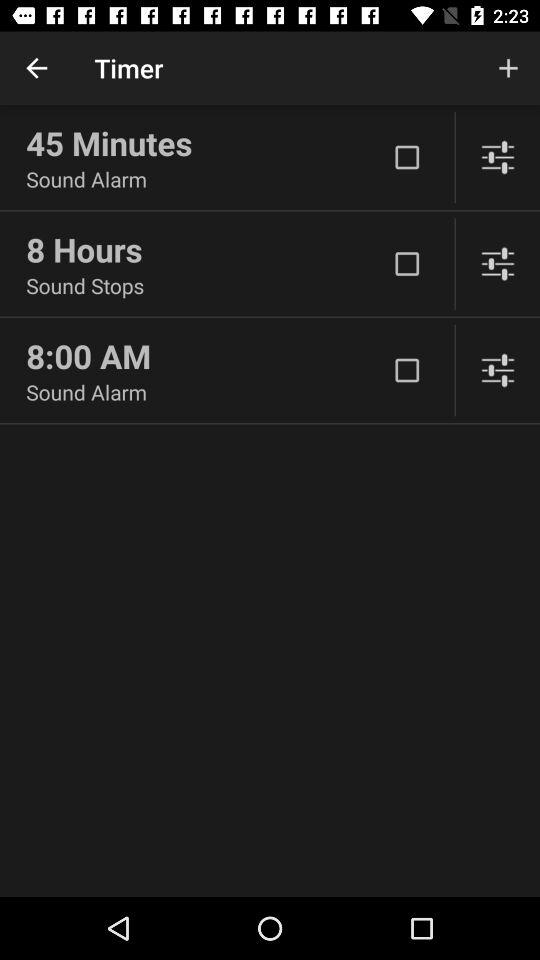Which item has the longest text?
Answer the question using a single word or phrase. 8 Hours 